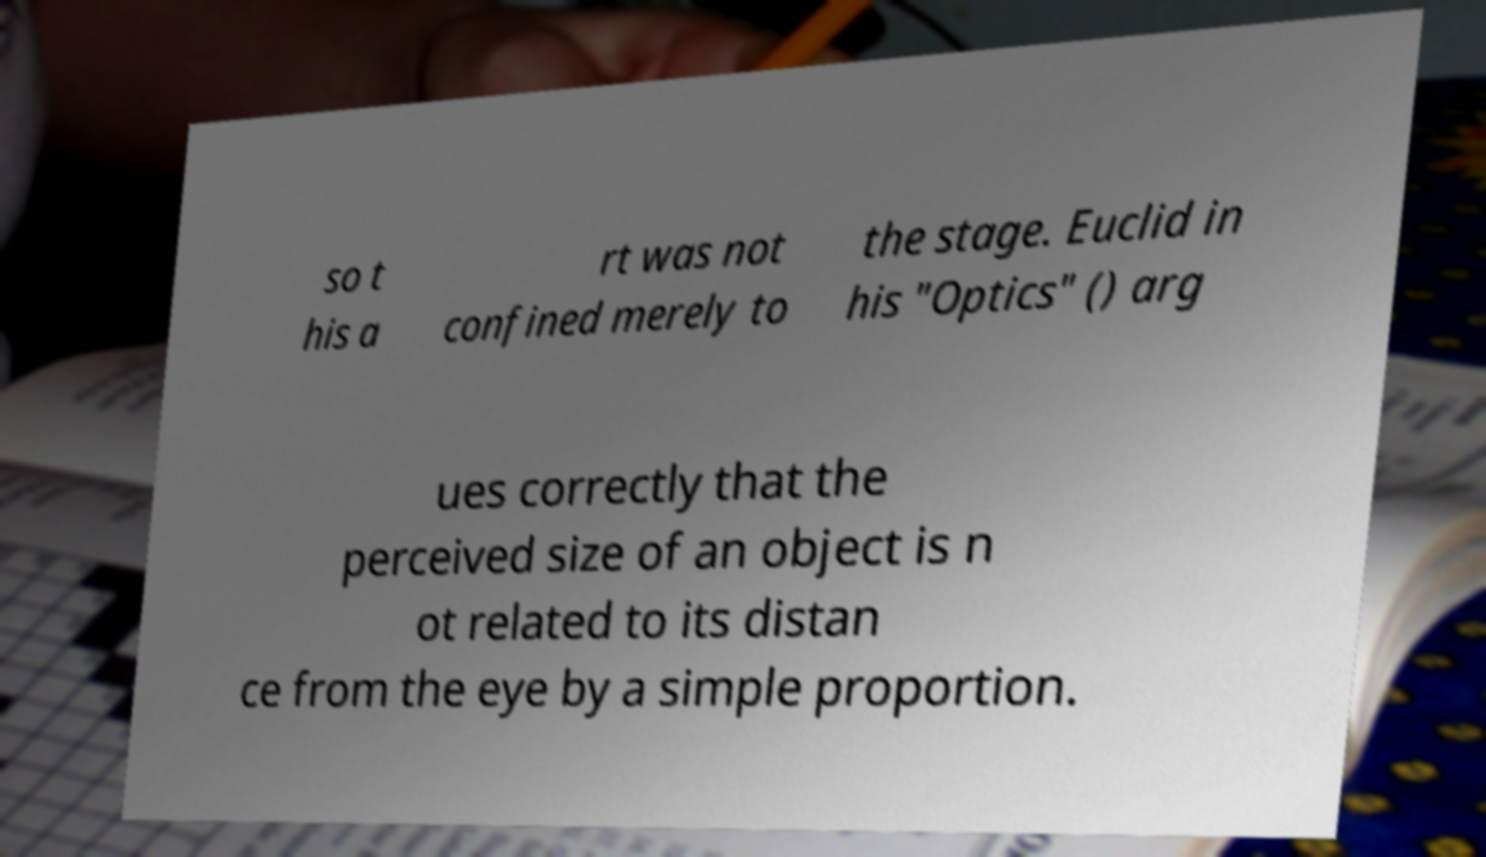What messages or text are displayed in this image? I need them in a readable, typed format. so t his a rt was not confined merely to the stage. Euclid in his "Optics" () arg ues correctly that the perceived size of an object is n ot related to its distan ce from the eye by a simple proportion. 